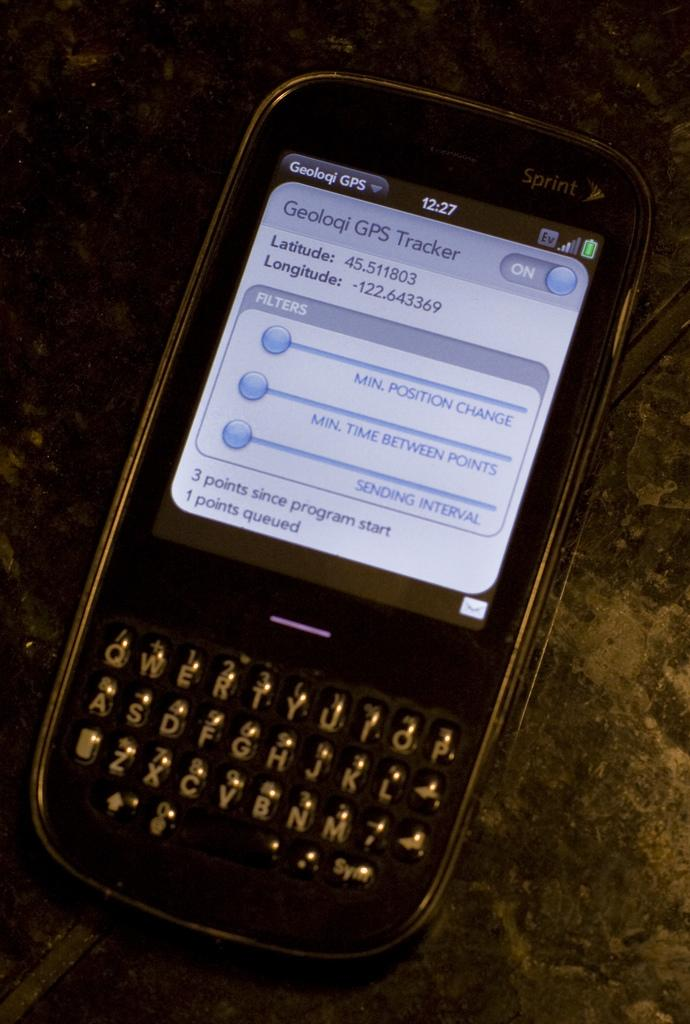<image>
Provide a brief description of the given image. A Sprint cellphone is displaying Geoloqi GPS on screen. 